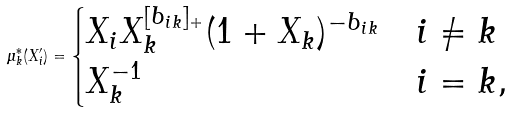<formula> <loc_0><loc_0><loc_500><loc_500>\mu _ { k } ^ { * } ( X ^ { \prime } _ { i } ) = \begin{cases} X _ { i } X _ { k } ^ { [ b _ { i k } ] _ { + } } ( 1 + X _ { k } ) ^ { - b _ { i k } } & i \neq k \\ X _ { k } ^ { - 1 } & i = k , \end{cases}</formula> 